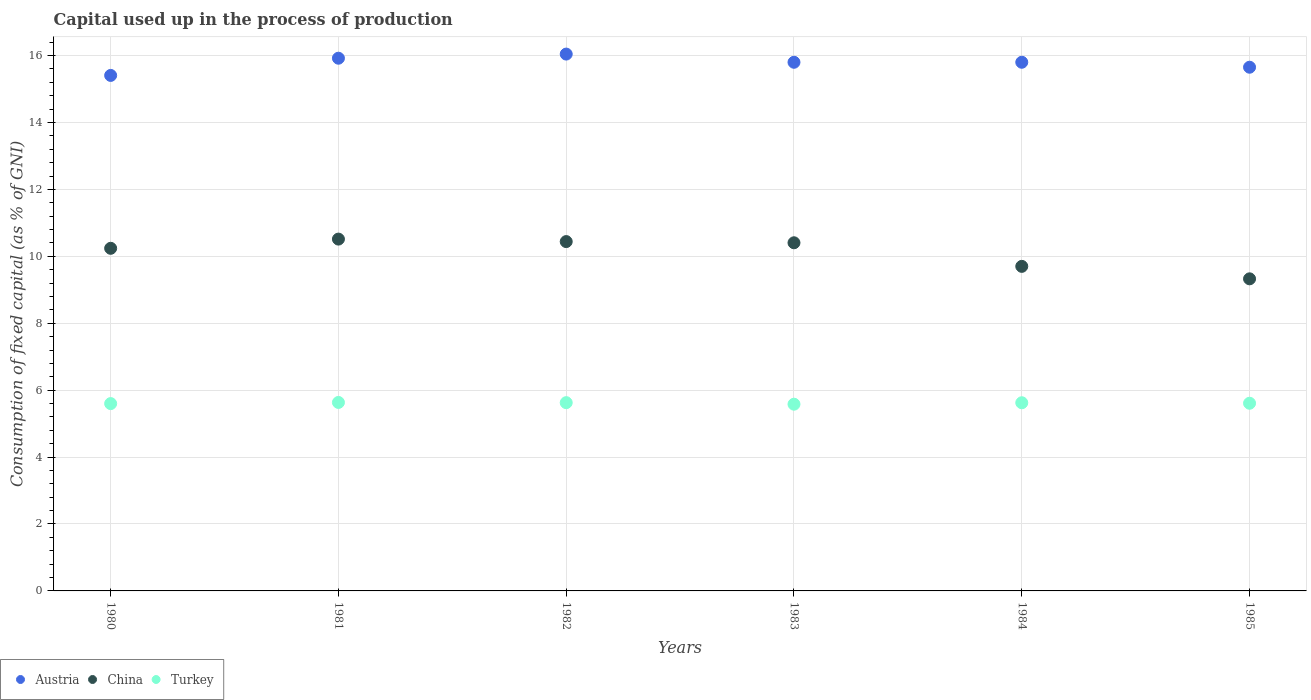How many different coloured dotlines are there?
Provide a short and direct response. 3. Is the number of dotlines equal to the number of legend labels?
Your response must be concise. Yes. What is the capital used up in the process of production in Turkey in 1984?
Offer a terse response. 5.62. Across all years, what is the maximum capital used up in the process of production in Austria?
Ensure brevity in your answer.  16.04. Across all years, what is the minimum capital used up in the process of production in Turkey?
Ensure brevity in your answer.  5.58. In which year was the capital used up in the process of production in Austria minimum?
Offer a very short reply. 1980. What is the total capital used up in the process of production in Turkey in the graph?
Provide a succinct answer. 33.67. What is the difference between the capital used up in the process of production in China in 1981 and that in 1984?
Provide a short and direct response. 0.81. What is the difference between the capital used up in the process of production in China in 1985 and the capital used up in the process of production in Turkey in 1980?
Make the answer very short. 3.73. What is the average capital used up in the process of production in Turkey per year?
Offer a terse response. 5.61. In the year 1980, what is the difference between the capital used up in the process of production in Austria and capital used up in the process of production in Turkey?
Your answer should be very brief. 9.81. In how many years, is the capital used up in the process of production in Austria greater than 10.8 %?
Keep it short and to the point. 6. What is the ratio of the capital used up in the process of production in Turkey in 1982 to that in 1984?
Provide a short and direct response. 1. Is the difference between the capital used up in the process of production in Austria in 1981 and 1982 greater than the difference between the capital used up in the process of production in Turkey in 1981 and 1982?
Offer a very short reply. No. What is the difference between the highest and the second highest capital used up in the process of production in China?
Offer a terse response. 0.07. What is the difference between the highest and the lowest capital used up in the process of production in Austria?
Your response must be concise. 0.64. Is it the case that in every year, the sum of the capital used up in the process of production in China and capital used up in the process of production in Austria  is greater than the capital used up in the process of production in Turkey?
Offer a terse response. Yes. Does the capital used up in the process of production in China monotonically increase over the years?
Provide a succinct answer. No. Is the capital used up in the process of production in China strictly greater than the capital used up in the process of production in Turkey over the years?
Your answer should be very brief. Yes. Is the capital used up in the process of production in China strictly less than the capital used up in the process of production in Austria over the years?
Your response must be concise. Yes. How many years are there in the graph?
Make the answer very short. 6. Are the values on the major ticks of Y-axis written in scientific E-notation?
Make the answer very short. No. Where does the legend appear in the graph?
Your response must be concise. Bottom left. How are the legend labels stacked?
Your answer should be very brief. Horizontal. What is the title of the graph?
Your response must be concise. Capital used up in the process of production. Does "Spain" appear as one of the legend labels in the graph?
Offer a very short reply. No. What is the label or title of the Y-axis?
Your answer should be compact. Consumption of fixed capital (as % of GNI). What is the Consumption of fixed capital (as % of GNI) of Austria in 1980?
Make the answer very short. 15.41. What is the Consumption of fixed capital (as % of GNI) of China in 1980?
Give a very brief answer. 10.24. What is the Consumption of fixed capital (as % of GNI) in Turkey in 1980?
Keep it short and to the point. 5.6. What is the Consumption of fixed capital (as % of GNI) of Austria in 1981?
Offer a terse response. 15.92. What is the Consumption of fixed capital (as % of GNI) in China in 1981?
Keep it short and to the point. 10.51. What is the Consumption of fixed capital (as % of GNI) of Turkey in 1981?
Offer a very short reply. 5.63. What is the Consumption of fixed capital (as % of GNI) of Austria in 1982?
Provide a short and direct response. 16.04. What is the Consumption of fixed capital (as % of GNI) in China in 1982?
Make the answer very short. 10.44. What is the Consumption of fixed capital (as % of GNI) of Turkey in 1982?
Make the answer very short. 5.63. What is the Consumption of fixed capital (as % of GNI) in Austria in 1983?
Your answer should be very brief. 15.8. What is the Consumption of fixed capital (as % of GNI) of China in 1983?
Make the answer very short. 10.4. What is the Consumption of fixed capital (as % of GNI) in Turkey in 1983?
Keep it short and to the point. 5.58. What is the Consumption of fixed capital (as % of GNI) of Austria in 1984?
Offer a terse response. 15.8. What is the Consumption of fixed capital (as % of GNI) in China in 1984?
Your answer should be very brief. 9.7. What is the Consumption of fixed capital (as % of GNI) in Turkey in 1984?
Offer a terse response. 5.62. What is the Consumption of fixed capital (as % of GNI) in Austria in 1985?
Give a very brief answer. 15.65. What is the Consumption of fixed capital (as % of GNI) in China in 1985?
Provide a short and direct response. 9.33. What is the Consumption of fixed capital (as % of GNI) of Turkey in 1985?
Your answer should be very brief. 5.61. Across all years, what is the maximum Consumption of fixed capital (as % of GNI) in Austria?
Your answer should be very brief. 16.04. Across all years, what is the maximum Consumption of fixed capital (as % of GNI) in China?
Provide a succinct answer. 10.51. Across all years, what is the maximum Consumption of fixed capital (as % of GNI) in Turkey?
Provide a succinct answer. 5.63. Across all years, what is the minimum Consumption of fixed capital (as % of GNI) of Austria?
Offer a terse response. 15.41. Across all years, what is the minimum Consumption of fixed capital (as % of GNI) of China?
Your response must be concise. 9.33. Across all years, what is the minimum Consumption of fixed capital (as % of GNI) in Turkey?
Provide a short and direct response. 5.58. What is the total Consumption of fixed capital (as % of GNI) in Austria in the graph?
Ensure brevity in your answer.  94.62. What is the total Consumption of fixed capital (as % of GNI) in China in the graph?
Provide a short and direct response. 60.63. What is the total Consumption of fixed capital (as % of GNI) of Turkey in the graph?
Provide a succinct answer. 33.67. What is the difference between the Consumption of fixed capital (as % of GNI) of Austria in 1980 and that in 1981?
Ensure brevity in your answer.  -0.51. What is the difference between the Consumption of fixed capital (as % of GNI) of China in 1980 and that in 1981?
Your response must be concise. -0.28. What is the difference between the Consumption of fixed capital (as % of GNI) in Turkey in 1980 and that in 1981?
Offer a terse response. -0.03. What is the difference between the Consumption of fixed capital (as % of GNI) in Austria in 1980 and that in 1982?
Your answer should be compact. -0.64. What is the difference between the Consumption of fixed capital (as % of GNI) in China in 1980 and that in 1982?
Make the answer very short. -0.2. What is the difference between the Consumption of fixed capital (as % of GNI) in Turkey in 1980 and that in 1982?
Your answer should be compact. -0.03. What is the difference between the Consumption of fixed capital (as % of GNI) of Austria in 1980 and that in 1983?
Give a very brief answer. -0.39. What is the difference between the Consumption of fixed capital (as % of GNI) of China in 1980 and that in 1983?
Keep it short and to the point. -0.17. What is the difference between the Consumption of fixed capital (as % of GNI) in Turkey in 1980 and that in 1983?
Your answer should be compact. 0.02. What is the difference between the Consumption of fixed capital (as % of GNI) in Austria in 1980 and that in 1984?
Provide a succinct answer. -0.39. What is the difference between the Consumption of fixed capital (as % of GNI) of China in 1980 and that in 1984?
Your answer should be compact. 0.54. What is the difference between the Consumption of fixed capital (as % of GNI) in Turkey in 1980 and that in 1984?
Your answer should be compact. -0.03. What is the difference between the Consumption of fixed capital (as % of GNI) in Austria in 1980 and that in 1985?
Your answer should be compact. -0.24. What is the difference between the Consumption of fixed capital (as % of GNI) in China in 1980 and that in 1985?
Provide a short and direct response. 0.91. What is the difference between the Consumption of fixed capital (as % of GNI) of Turkey in 1980 and that in 1985?
Make the answer very short. -0.01. What is the difference between the Consumption of fixed capital (as % of GNI) of Austria in 1981 and that in 1982?
Provide a succinct answer. -0.12. What is the difference between the Consumption of fixed capital (as % of GNI) of China in 1981 and that in 1982?
Keep it short and to the point. 0.07. What is the difference between the Consumption of fixed capital (as % of GNI) in Turkey in 1981 and that in 1982?
Provide a short and direct response. 0.01. What is the difference between the Consumption of fixed capital (as % of GNI) in Austria in 1981 and that in 1983?
Provide a succinct answer. 0.12. What is the difference between the Consumption of fixed capital (as % of GNI) of China in 1981 and that in 1983?
Your answer should be very brief. 0.11. What is the difference between the Consumption of fixed capital (as % of GNI) of Turkey in 1981 and that in 1983?
Provide a short and direct response. 0.05. What is the difference between the Consumption of fixed capital (as % of GNI) of Austria in 1981 and that in 1984?
Your answer should be very brief. 0.12. What is the difference between the Consumption of fixed capital (as % of GNI) in China in 1981 and that in 1984?
Keep it short and to the point. 0.81. What is the difference between the Consumption of fixed capital (as % of GNI) in Turkey in 1981 and that in 1984?
Give a very brief answer. 0.01. What is the difference between the Consumption of fixed capital (as % of GNI) in Austria in 1981 and that in 1985?
Keep it short and to the point. 0.27. What is the difference between the Consumption of fixed capital (as % of GNI) of China in 1981 and that in 1985?
Give a very brief answer. 1.19. What is the difference between the Consumption of fixed capital (as % of GNI) of Turkey in 1981 and that in 1985?
Ensure brevity in your answer.  0.02. What is the difference between the Consumption of fixed capital (as % of GNI) of Austria in 1982 and that in 1983?
Ensure brevity in your answer.  0.24. What is the difference between the Consumption of fixed capital (as % of GNI) of China in 1982 and that in 1983?
Offer a very short reply. 0.04. What is the difference between the Consumption of fixed capital (as % of GNI) in Turkey in 1982 and that in 1983?
Your response must be concise. 0.05. What is the difference between the Consumption of fixed capital (as % of GNI) in Austria in 1982 and that in 1984?
Make the answer very short. 0.24. What is the difference between the Consumption of fixed capital (as % of GNI) of China in 1982 and that in 1984?
Provide a succinct answer. 0.74. What is the difference between the Consumption of fixed capital (as % of GNI) of Turkey in 1982 and that in 1984?
Your answer should be compact. 0. What is the difference between the Consumption of fixed capital (as % of GNI) of Austria in 1982 and that in 1985?
Your response must be concise. 0.39. What is the difference between the Consumption of fixed capital (as % of GNI) of China in 1982 and that in 1985?
Offer a very short reply. 1.11. What is the difference between the Consumption of fixed capital (as % of GNI) of Turkey in 1982 and that in 1985?
Give a very brief answer. 0.02. What is the difference between the Consumption of fixed capital (as % of GNI) in Austria in 1983 and that in 1984?
Ensure brevity in your answer.  -0. What is the difference between the Consumption of fixed capital (as % of GNI) in China in 1983 and that in 1984?
Make the answer very short. 0.7. What is the difference between the Consumption of fixed capital (as % of GNI) of Turkey in 1983 and that in 1984?
Provide a succinct answer. -0.04. What is the difference between the Consumption of fixed capital (as % of GNI) in Austria in 1983 and that in 1985?
Offer a terse response. 0.15. What is the difference between the Consumption of fixed capital (as % of GNI) of China in 1983 and that in 1985?
Keep it short and to the point. 1.08. What is the difference between the Consumption of fixed capital (as % of GNI) in Turkey in 1983 and that in 1985?
Keep it short and to the point. -0.03. What is the difference between the Consumption of fixed capital (as % of GNI) in Austria in 1984 and that in 1985?
Make the answer very short. 0.15. What is the difference between the Consumption of fixed capital (as % of GNI) of China in 1984 and that in 1985?
Ensure brevity in your answer.  0.37. What is the difference between the Consumption of fixed capital (as % of GNI) in Turkey in 1984 and that in 1985?
Offer a terse response. 0.01. What is the difference between the Consumption of fixed capital (as % of GNI) in Austria in 1980 and the Consumption of fixed capital (as % of GNI) in China in 1981?
Provide a succinct answer. 4.89. What is the difference between the Consumption of fixed capital (as % of GNI) in Austria in 1980 and the Consumption of fixed capital (as % of GNI) in Turkey in 1981?
Provide a short and direct response. 9.77. What is the difference between the Consumption of fixed capital (as % of GNI) in China in 1980 and the Consumption of fixed capital (as % of GNI) in Turkey in 1981?
Provide a short and direct response. 4.61. What is the difference between the Consumption of fixed capital (as % of GNI) in Austria in 1980 and the Consumption of fixed capital (as % of GNI) in China in 1982?
Provide a succinct answer. 4.97. What is the difference between the Consumption of fixed capital (as % of GNI) in Austria in 1980 and the Consumption of fixed capital (as % of GNI) in Turkey in 1982?
Provide a succinct answer. 9.78. What is the difference between the Consumption of fixed capital (as % of GNI) in China in 1980 and the Consumption of fixed capital (as % of GNI) in Turkey in 1982?
Your answer should be compact. 4.61. What is the difference between the Consumption of fixed capital (as % of GNI) of Austria in 1980 and the Consumption of fixed capital (as % of GNI) of China in 1983?
Your answer should be compact. 5. What is the difference between the Consumption of fixed capital (as % of GNI) of Austria in 1980 and the Consumption of fixed capital (as % of GNI) of Turkey in 1983?
Make the answer very short. 9.83. What is the difference between the Consumption of fixed capital (as % of GNI) in China in 1980 and the Consumption of fixed capital (as % of GNI) in Turkey in 1983?
Your response must be concise. 4.66. What is the difference between the Consumption of fixed capital (as % of GNI) of Austria in 1980 and the Consumption of fixed capital (as % of GNI) of China in 1984?
Provide a succinct answer. 5.71. What is the difference between the Consumption of fixed capital (as % of GNI) of Austria in 1980 and the Consumption of fixed capital (as % of GNI) of Turkey in 1984?
Keep it short and to the point. 9.78. What is the difference between the Consumption of fixed capital (as % of GNI) in China in 1980 and the Consumption of fixed capital (as % of GNI) in Turkey in 1984?
Your answer should be very brief. 4.62. What is the difference between the Consumption of fixed capital (as % of GNI) of Austria in 1980 and the Consumption of fixed capital (as % of GNI) of China in 1985?
Provide a short and direct response. 6.08. What is the difference between the Consumption of fixed capital (as % of GNI) of Austria in 1980 and the Consumption of fixed capital (as % of GNI) of Turkey in 1985?
Ensure brevity in your answer.  9.8. What is the difference between the Consumption of fixed capital (as % of GNI) of China in 1980 and the Consumption of fixed capital (as % of GNI) of Turkey in 1985?
Provide a short and direct response. 4.63. What is the difference between the Consumption of fixed capital (as % of GNI) of Austria in 1981 and the Consumption of fixed capital (as % of GNI) of China in 1982?
Your answer should be very brief. 5.48. What is the difference between the Consumption of fixed capital (as % of GNI) of Austria in 1981 and the Consumption of fixed capital (as % of GNI) of Turkey in 1982?
Your answer should be very brief. 10.29. What is the difference between the Consumption of fixed capital (as % of GNI) in China in 1981 and the Consumption of fixed capital (as % of GNI) in Turkey in 1982?
Make the answer very short. 4.89. What is the difference between the Consumption of fixed capital (as % of GNI) of Austria in 1981 and the Consumption of fixed capital (as % of GNI) of China in 1983?
Offer a very short reply. 5.52. What is the difference between the Consumption of fixed capital (as % of GNI) of Austria in 1981 and the Consumption of fixed capital (as % of GNI) of Turkey in 1983?
Make the answer very short. 10.34. What is the difference between the Consumption of fixed capital (as % of GNI) of China in 1981 and the Consumption of fixed capital (as % of GNI) of Turkey in 1983?
Offer a very short reply. 4.93. What is the difference between the Consumption of fixed capital (as % of GNI) in Austria in 1981 and the Consumption of fixed capital (as % of GNI) in China in 1984?
Offer a very short reply. 6.22. What is the difference between the Consumption of fixed capital (as % of GNI) of Austria in 1981 and the Consumption of fixed capital (as % of GNI) of Turkey in 1984?
Provide a succinct answer. 10.3. What is the difference between the Consumption of fixed capital (as % of GNI) in China in 1981 and the Consumption of fixed capital (as % of GNI) in Turkey in 1984?
Ensure brevity in your answer.  4.89. What is the difference between the Consumption of fixed capital (as % of GNI) in Austria in 1981 and the Consumption of fixed capital (as % of GNI) in China in 1985?
Provide a short and direct response. 6.59. What is the difference between the Consumption of fixed capital (as % of GNI) of Austria in 1981 and the Consumption of fixed capital (as % of GNI) of Turkey in 1985?
Keep it short and to the point. 10.31. What is the difference between the Consumption of fixed capital (as % of GNI) of China in 1981 and the Consumption of fixed capital (as % of GNI) of Turkey in 1985?
Give a very brief answer. 4.91. What is the difference between the Consumption of fixed capital (as % of GNI) in Austria in 1982 and the Consumption of fixed capital (as % of GNI) in China in 1983?
Your answer should be compact. 5.64. What is the difference between the Consumption of fixed capital (as % of GNI) of Austria in 1982 and the Consumption of fixed capital (as % of GNI) of Turkey in 1983?
Keep it short and to the point. 10.46. What is the difference between the Consumption of fixed capital (as % of GNI) of China in 1982 and the Consumption of fixed capital (as % of GNI) of Turkey in 1983?
Give a very brief answer. 4.86. What is the difference between the Consumption of fixed capital (as % of GNI) of Austria in 1982 and the Consumption of fixed capital (as % of GNI) of China in 1984?
Your answer should be compact. 6.34. What is the difference between the Consumption of fixed capital (as % of GNI) of Austria in 1982 and the Consumption of fixed capital (as % of GNI) of Turkey in 1984?
Your response must be concise. 10.42. What is the difference between the Consumption of fixed capital (as % of GNI) in China in 1982 and the Consumption of fixed capital (as % of GNI) in Turkey in 1984?
Your answer should be very brief. 4.82. What is the difference between the Consumption of fixed capital (as % of GNI) of Austria in 1982 and the Consumption of fixed capital (as % of GNI) of China in 1985?
Ensure brevity in your answer.  6.72. What is the difference between the Consumption of fixed capital (as % of GNI) in Austria in 1982 and the Consumption of fixed capital (as % of GNI) in Turkey in 1985?
Your answer should be compact. 10.44. What is the difference between the Consumption of fixed capital (as % of GNI) of China in 1982 and the Consumption of fixed capital (as % of GNI) of Turkey in 1985?
Offer a very short reply. 4.83. What is the difference between the Consumption of fixed capital (as % of GNI) in Austria in 1983 and the Consumption of fixed capital (as % of GNI) in China in 1984?
Your answer should be very brief. 6.1. What is the difference between the Consumption of fixed capital (as % of GNI) of Austria in 1983 and the Consumption of fixed capital (as % of GNI) of Turkey in 1984?
Ensure brevity in your answer.  10.18. What is the difference between the Consumption of fixed capital (as % of GNI) in China in 1983 and the Consumption of fixed capital (as % of GNI) in Turkey in 1984?
Give a very brief answer. 4.78. What is the difference between the Consumption of fixed capital (as % of GNI) in Austria in 1983 and the Consumption of fixed capital (as % of GNI) in China in 1985?
Ensure brevity in your answer.  6.47. What is the difference between the Consumption of fixed capital (as % of GNI) of Austria in 1983 and the Consumption of fixed capital (as % of GNI) of Turkey in 1985?
Give a very brief answer. 10.19. What is the difference between the Consumption of fixed capital (as % of GNI) in China in 1983 and the Consumption of fixed capital (as % of GNI) in Turkey in 1985?
Give a very brief answer. 4.8. What is the difference between the Consumption of fixed capital (as % of GNI) of Austria in 1984 and the Consumption of fixed capital (as % of GNI) of China in 1985?
Your response must be concise. 6.47. What is the difference between the Consumption of fixed capital (as % of GNI) in Austria in 1984 and the Consumption of fixed capital (as % of GNI) in Turkey in 1985?
Your answer should be very brief. 10.19. What is the difference between the Consumption of fixed capital (as % of GNI) of China in 1984 and the Consumption of fixed capital (as % of GNI) of Turkey in 1985?
Offer a very short reply. 4.09. What is the average Consumption of fixed capital (as % of GNI) in Austria per year?
Your answer should be compact. 15.77. What is the average Consumption of fixed capital (as % of GNI) of China per year?
Make the answer very short. 10.1. What is the average Consumption of fixed capital (as % of GNI) in Turkey per year?
Provide a short and direct response. 5.61. In the year 1980, what is the difference between the Consumption of fixed capital (as % of GNI) in Austria and Consumption of fixed capital (as % of GNI) in China?
Your answer should be compact. 5.17. In the year 1980, what is the difference between the Consumption of fixed capital (as % of GNI) in Austria and Consumption of fixed capital (as % of GNI) in Turkey?
Your answer should be compact. 9.81. In the year 1980, what is the difference between the Consumption of fixed capital (as % of GNI) in China and Consumption of fixed capital (as % of GNI) in Turkey?
Your answer should be very brief. 4.64. In the year 1981, what is the difference between the Consumption of fixed capital (as % of GNI) in Austria and Consumption of fixed capital (as % of GNI) in China?
Give a very brief answer. 5.41. In the year 1981, what is the difference between the Consumption of fixed capital (as % of GNI) of Austria and Consumption of fixed capital (as % of GNI) of Turkey?
Provide a succinct answer. 10.29. In the year 1981, what is the difference between the Consumption of fixed capital (as % of GNI) of China and Consumption of fixed capital (as % of GNI) of Turkey?
Keep it short and to the point. 4.88. In the year 1982, what is the difference between the Consumption of fixed capital (as % of GNI) of Austria and Consumption of fixed capital (as % of GNI) of China?
Your response must be concise. 5.6. In the year 1982, what is the difference between the Consumption of fixed capital (as % of GNI) of Austria and Consumption of fixed capital (as % of GNI) of Turkey?
Keep it short and to the point. 10.42. In the year 1982, what is the difference between the Consumption of fixed capital (as % of GNI) of China and Consumption of fixed capital (as % of GNI) of Turkey?
Make the answer very short. 4.81. In the year 1983, what is the difference between the Consumption of fixed capital (as % of GNI) in Austria and Consumption of fixed capital (as % of GNI) in China?
Provide a short and direct response. 5.39. In the year 1983, what is the difference between the Consumption of fixed capital (as % of GNI) in Austria and Consumption of fixed capital (as % of GNI) in Turkey?
Ensure brevity in your answer.  10.22. In the year 1983, what is the difference between the Consumption of fixed capital (as % of GNI) in China and Consumption of fixed capital (as % of GNI) in Turkey?
Provide a short and direct response. 4.82. In the year 1984, what is the difference between the Consumption of fixed capital (as % of GNI) in Austria and Consumption of fixed capital (as % of GNI) in China?
Offer a very short reply. 6.1. In the year 1984, what is the difference between the Consumption of fixed capital (as % of GNI) of Austria and Consumption of fixed capital (as % of GNI) of Turkey?
Offer a very short reply. 10.18. In the year 1984, what is the difference between the Consumption of fixed capital (as % of GNI) in China and Consumption of fixed capital (as % of GNI) in Turkey?
Make the answer very short. 4.08. In the year 1985, what is the difference between the Consumption of fixed capital (as % of GNI) in Austria and Consumption of fixed capital (as % of GNI) in China?
Provide a short and direct response. 6.32. In the year 1985, what is the difference between the Consumption of fixed capital (as % of GNI) in Austria and Consumption of fixed capital (as % of GNI) in Turkey?
Ensure brevity in your answer.  10.04. In the year 1985, what is the difference between the Consumption of fixed capital (as % of GNI) in China and Consumption of fixed capital (as % of GNI) in Turkey?
Keep it short and to the point. 3.72. What is the ratio of the Consumption of fixed capital (as % of GNI) in China in 1980 to that in 1981?
Ensure brevity in your answer.  0.97. What is the ratio of the Consumption of fixed capital (as % of GNI) in Austria in 1980 to that in 1982?
Give a very brief answer. 0.96. What is the ratio of the Consumption of fixed capital (as % of GNI) in China in 1980 to that in 1982?
Ensure brevity in your answer.  0.98. What is the ratio of the Consumption of fixed capital (as % of GNI) in Turkey in 1980 to that in 1982?
Provide a succinct answer. 0.99. What is the ratio of the Consumption of fixed capital (as % of GNI) in Austria in 1980 to that in 1983?
Your response must be concise. 0.98. What is the ratio of the Consumption of fixed capital (as % of GNI) in China in 1980 to that in 1983?
Ensure brevity in your answer.  0.98. What is the ratio of the Consumption of fixed capital (as % of GNI) in Austria in 1980 to that in 1984?
Your response must be concise. 0.98. What is the ratio of the Consumption of fixed capital (as % of GNI) in China in 1980 to that in 1984?
Your answer should be very brief. 1.06. What is the ratio of the Consumption of fixed capital (as % of GNI) in Turkey in 1980 to that in 1984?
Your answer should be compact. 1. What is the ratio of the Consumption of fixed capital (as % of GNI) in Austria in 1980 to that in 1985?
Your answer should be compact. 0.98. What is the ratio of the Consumption of fixed capital (as % of GNI) in China in 1980 to that in 1985?
Your response must be concise. 1.1. What is the ratio of the Consumption of fixed capital (as % of GNI) of China in 1981 to that in 1982?
Offer a terse response. 1.01. What is the ratio of the Consumption of fixed capital (as % of GNI) in Turkey in 1981 to that in 1982?
Your response must be concise. 1. What is the ratio of the Consumption of fixed capital (as % of GNI) in Austria in 1981 to that in 1983?
Your response must be concise. 1.01. What is the ratio of the Consumption of fixed capital (as % of GNI) in China in 1981 to that in 1983?
Give a very brief answer. 1.01. What is the ratio of the Consumption of fixed capital (as % of GNI) in Turkey in 1981 to that in 1983?
Offer a terse response. 1.01. What is the ratio of the Consumption of fixed capital (as % of GNI) in Austria in 1981 to that in 1984?
Provide a short and direct response. 1.01. What is the ratio of the Consumption of fixed capital (as % of GNI) in China in 1981 to that in 1984?
Your answer should be compact. 1.08. What is the ratio of the Consumption of fixed capital (as % of GNI) of Turkey in 1981 to that in 1984?
Offer a very short reply. 1. What is the ratio of the Consumption of fixed capital (as % of GNI) of Austria in 1981 to that in 1985?
Provide a short and direct response. 1.02. What is the ratio of the Consumption of fixed capital (as % of GNI) of China in 1981 to that in 1985?
Provide a short and direct response. 1.13. What is the ratio of the Consumption of fixed capital (as % of GNI) of Austria in 1982 to that in 1983?
Keep it short and to the point. 1.02. What is the ratio of the Consumption of fixed capital (as % of GNI) of Turkey in 1982 to that in 1983?
Ensure brevity in your answer.  1.01. What is the ratio of the Consumption of fixed capital (as % of GNI) in Austria in 1982 to that in 1984?
Your answer should be very brief. 1.02. What is the ratio of the Consumption of fixed capital (as % of GNI) in China in 1982 to that in 1984?
Keep it short and to the point. 1.08. What is the ratio of the Consumption of fixed capital (as % of GNI) in Turkey in 1982 to that in 1984?
Ensure brevity in your answer.  1. What is the ratio of the Consumption of fixed capital (as % of GNI) of Austria in 1982 to that in 1985?
Make the answer very short. 1.03. What is the ratio of the Consumption of fixed capital (as % of GNI) in China in 1982 to that in 1985?
Keep it short and to the point. 1.12. What is the ratio of the Consumption of fixed capital (as % of GNI) in Turkey in 1982 to that in 1985?
Your answer should be very brief. 1. What is the ratio of the Consumption of fixed capital (as % of GNI) in China in 1983 to that in 1984?
Ensure brevity in your answer.  1.07. What is the ratio of the Consumption of fixed capital (as % of GNI) of Austria in 1983 to that in 1985?
Your response must be concise. 1.01. What is the ratio of the Consumption of fixed capital (as % of GNI) in China in 1983 to that in 1985?
Give a very brief answer. 1.12. What is the ratio of the Consumption of fixed capital (as % of GNI) of Turkey in 1983 to that in 1985?
Your answer should be compact. 0.99. What is the ratio of the Consumption of fixed capital (as % of GNI) in Austria in 1984 to that in 1985?
Provide a short and direct response. 1.01. What is the ratio of the Consumption of fixed capital (as % of GNI) in China in 1984 to that in 1985?
Your response must be concise. 1.04. What is the ratio of the Consumption of fixed capital (as % of GNI) in Turkey in 1984 to that in 1985?
Your answer should be compact. 1. What is the difference between the highest and the second highest Consumption of fixed capital (as % of GNI) of Austria?
Offer a terse response. 0.12. What is the difference between the highest and the second highest Consumption of fixed capital (as % of GNI) of China?
Provide a short and direct response. 0.07. What is the difference between the highest and the second highest Consumption of fixed capital (as % of GNI) of Turkey?
Offer a very short reply. 0.01. What is the difference between the highest and the lowest Consumption of fixed capital (as % of GNI) in Austria?
Your answer should be very brief. 0.64. What is the difference between the highest and the lowest Consumption of fixed capital (as % of GNI) in China?
Offer a very short reply. 1.19. What is the difference between the highest and the lowest Consumption of fixed capital (as % of GNI) in Turkey?
Your response must be concise. 0.05. 